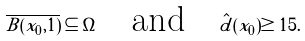<formula> <loc_0><loc_0><loc_500><loc_500>\overline { B ( x _ { 0 } , 1 ) } \subseteq \Omega \quad \text {and} \quad \hat { d } ( x _ { 0 } ) \geq 1 5 .</formula> 